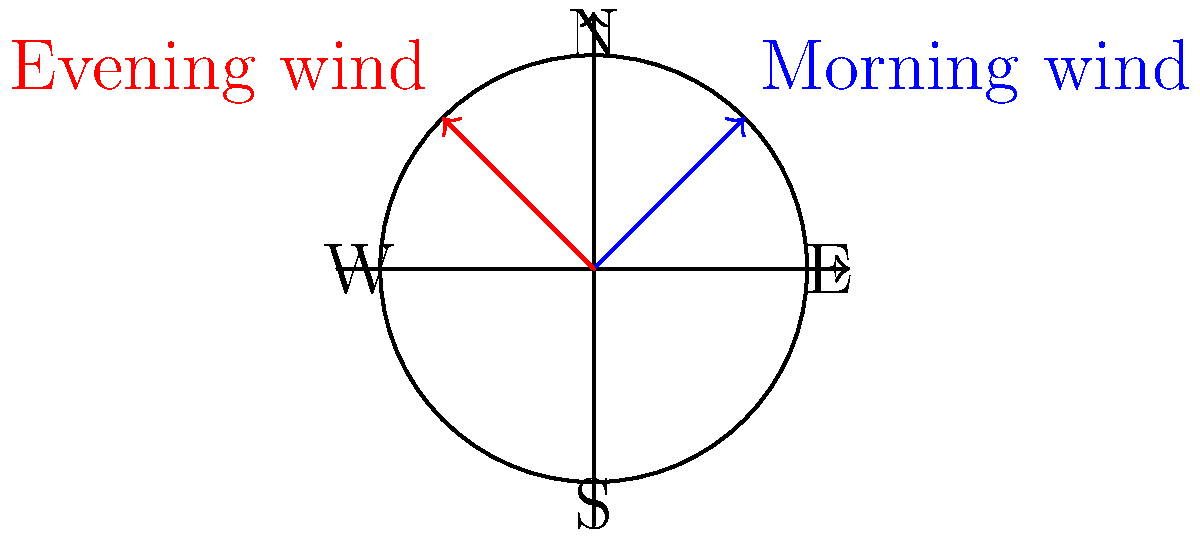As a cautious commuter in the Gull Lake area, you're monitoring wind conditions affecting road safety. The morning wind is blowing at 30 km/h from the northeast (45°), while the evening wind is coming from the northwest (135°) at 40 km/h. Using polar coordinates, what is the total vector sum of these two wind conditions? Express your answer in the form $(r, \theta)$, where $r$ is rounded to the nearest whole number and $\theta$ is in degrees, rounded to the nearest degree. Let's approach this step-by-step:

1) First, we need to convert the given information into polar coordinates:
   Morning wind: $(30, 45°)$
   Evening wind: $(40, 135°)$

2) Now, we need to convert these polar coordinates to rectangular coordinates:
   Morning wind: 
   $x_1 = 30 \cos(45°) = 30 \cdot \frac{\sqrt{2}}{2} \approx 21.21$
   $y_1 = 30 \sin(45°) = 30 \cdot \frac{\sqrt{2}}{2} \approx 21.21$

   Evening wind:
   $x_2 = 40 \cos(135°) = 40 \cdot (-\frac{\sqrt{2}}{2}) \approx -28.28$
   $y_2 = 40 \sin(135°) = 40 \cdot \frac{\sqrt{2}}{2} \approx 28.28$

3) Add the x and y components:
   $x_{total} = x_1 + x_2 = 21.21 + (-28.28) = -7.07$
   $y_{total} = y_1 + y_2 = 21.21 + 28.28 = 49.49$

4) Convert back to polar coordinates:
   $r = \sqrt{x_{total}^2 + y_{total}^2} = \sqrt{(-7.07)^2 + 49.49^2} \approx 50.0$

   $\theta = \tan^{-1}(\frac{y_{total}}{x_{total}}) = \tan^{-1}(\frac{49.49}{-7.07}) \approx 98.1°$

5) Adjust the angle to the correct quadrant (II quadrant in this case):
   $\theta = 98.1°$ (no adjustment needed as it's already in the correct quadrant)

6) Round $r$ to the nearest whole number and $\theta$ to the nearest degree:
   $r \approx 50$
   $\theta \approx 98°$
Answer: $(50, 98°)$ 